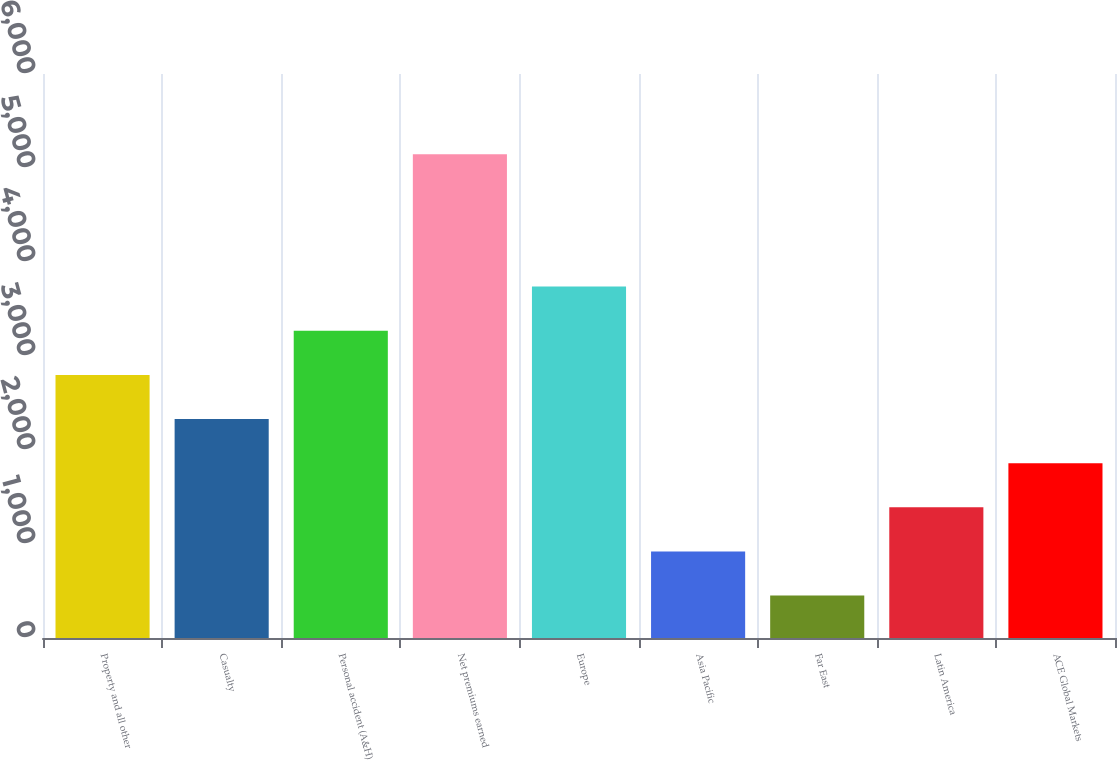Convert chart. <chart><loc_0><loc_0><loc_500><loc_500><bar_chart><fcel>Property and all other<fcel>Casualty<fcel>Personal accident (A&H)<fcel>Net premiums earned<fcel>Europe<fcel>Asia Pacific<fcel>Far East<fcel>Latin America<fcel>ACE Global Markets<nl><fcel>2799<fcel>2329.4<fcel>3268.6<fcel>5147<fcel>3738.2<fcel>920.6<fcel>451<fcel>1390.2<fcel>1859.8<nl></chart> 